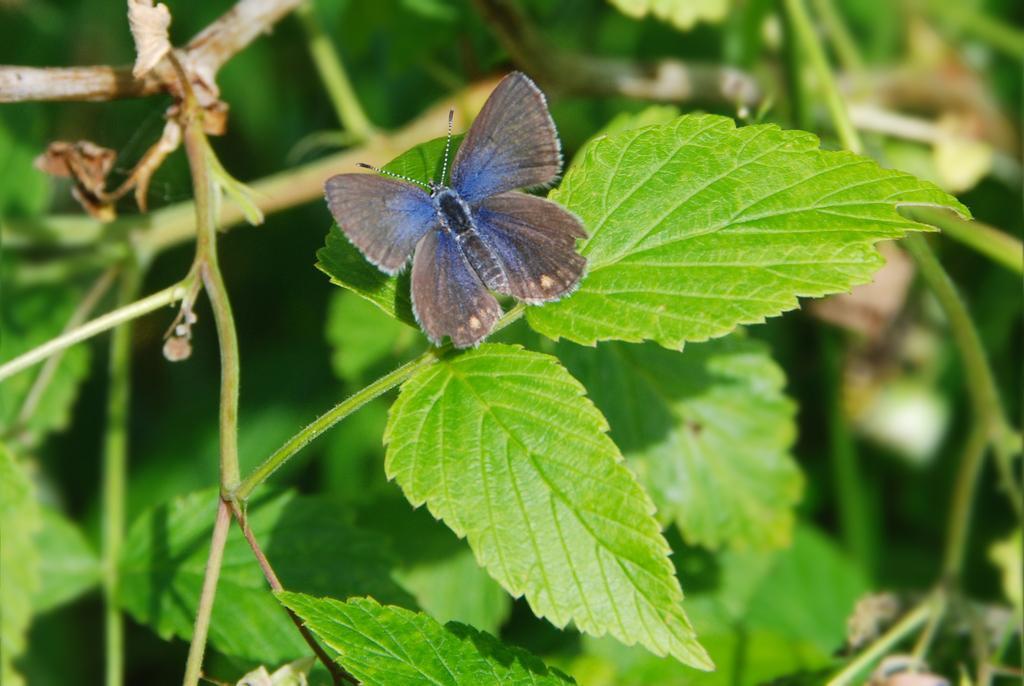In one or two sentences, can you explain what this image depicts? This image consists of a butterfly on a leaf. The leaves are in green color. 